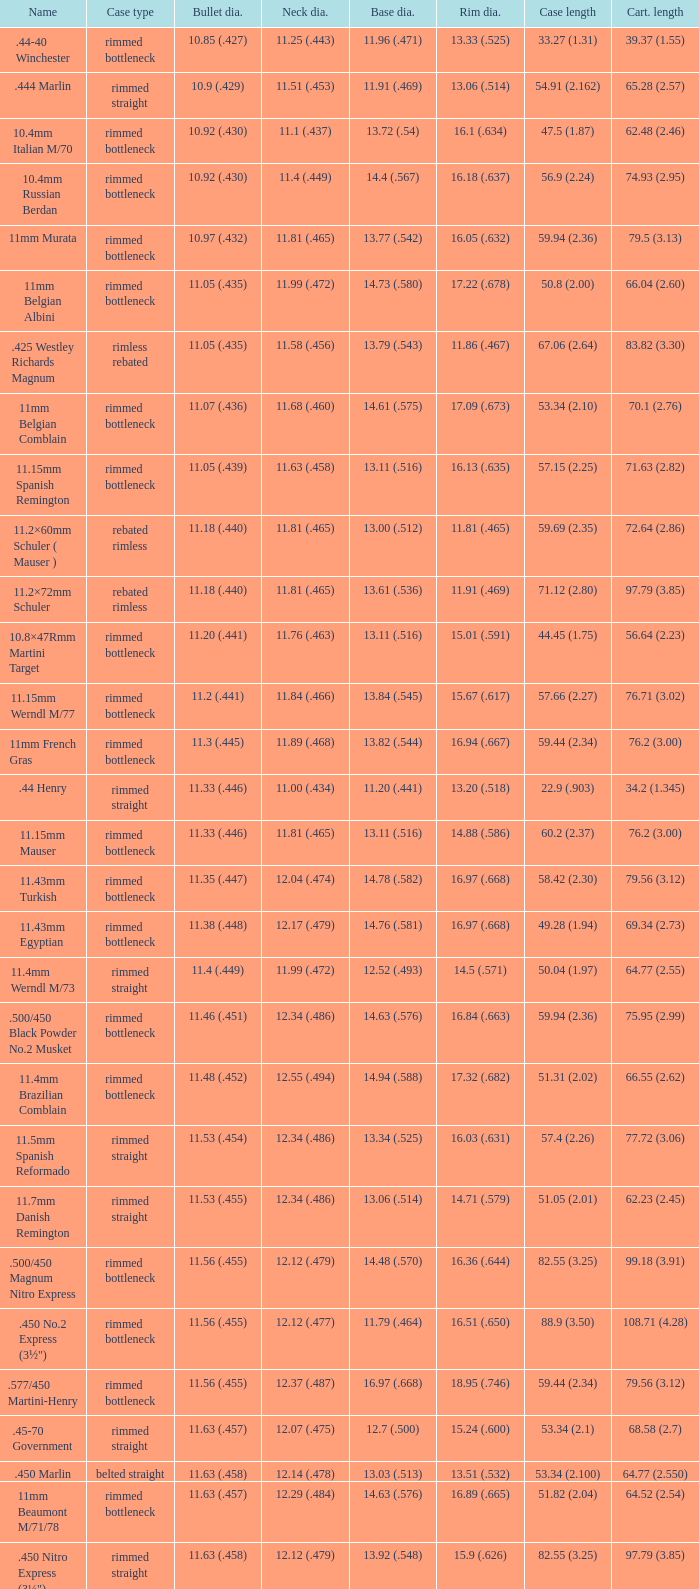Which Case type has a Base diameter of 13.03 (.513), and a Case length of 63.5 (2.5)? Belted straight. 